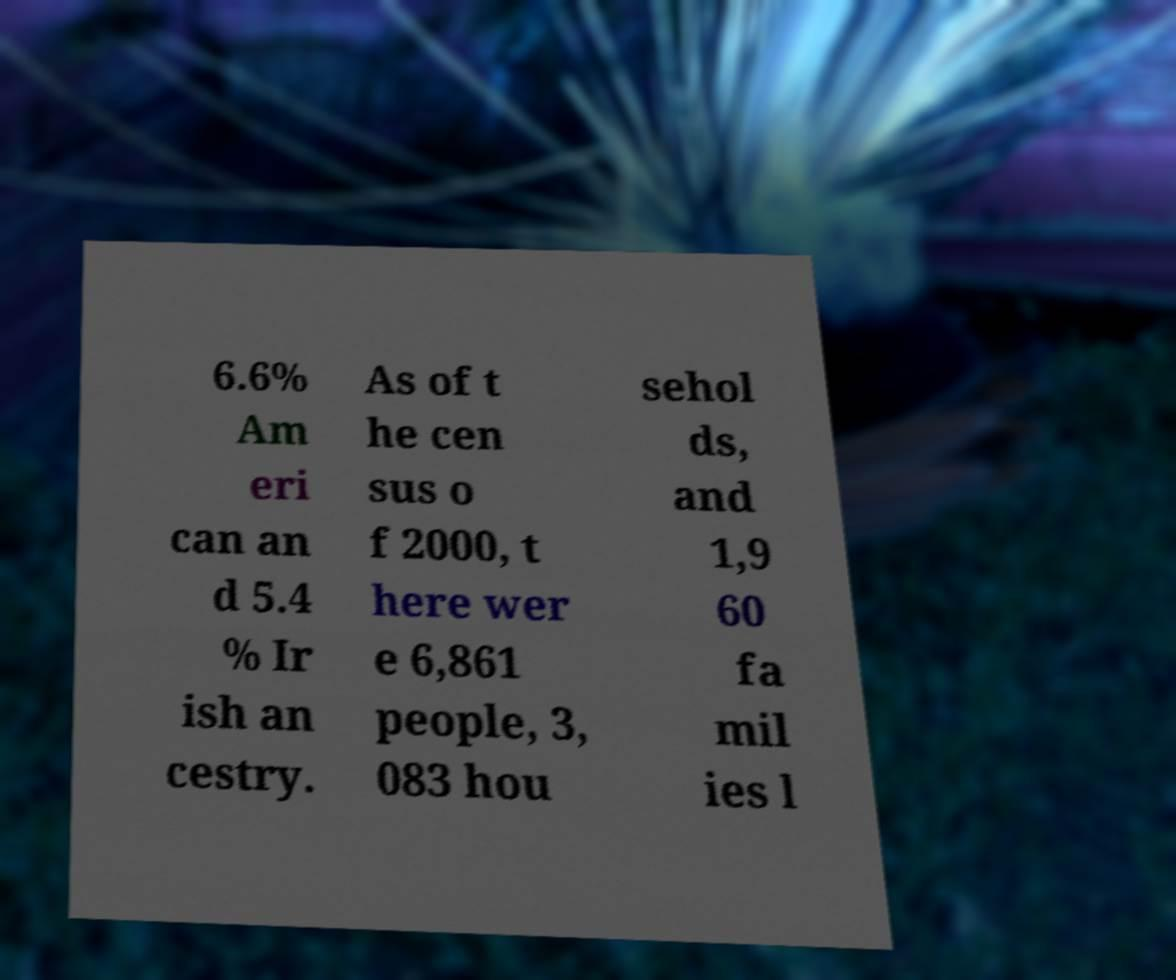Can you read and provide the text displayed in the image?This photo seems to have some interesting text. Can you extract and type it out for me? 6.6% Am eri can an d 5.4 % Ir ish an cestry. As of t he cen sus o f 2000, t here wer e 6,861 people, 3, 083 hou sehol ds, and 1,9 60 fa mil ies l 